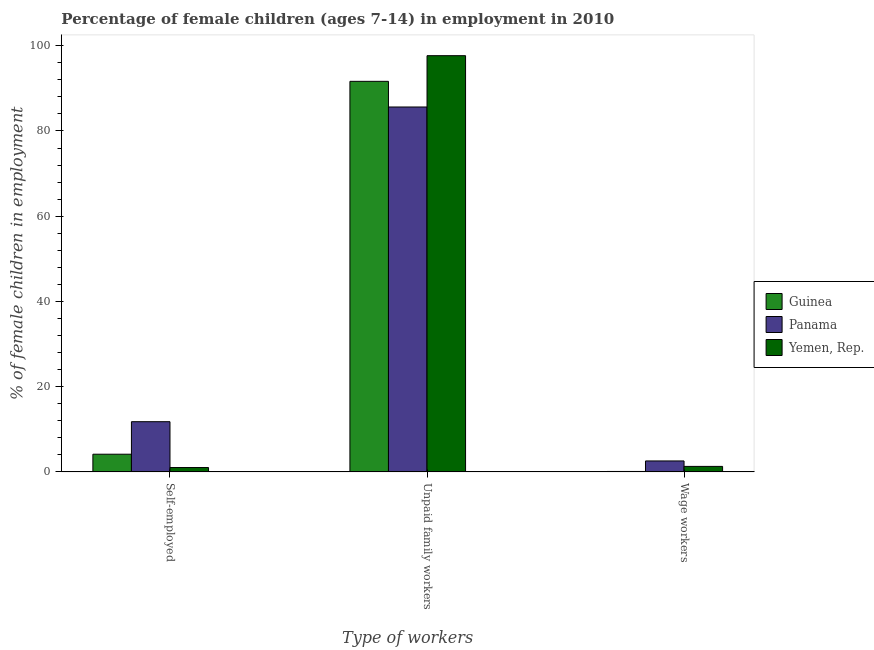How many groups of bars are there?
Keep it short and to the point. 3. Are the number of bars per tick equal to the number of legend labels?
Your response must be concise. Yes. What is the label of the 1st group of bars from the left?
Keep it short and to the point. Self-employed. What is the percentage of children employed as wage workers in Guinea?
Provide a succinct answer. 0.11. Across all countries, what is the maximum percentage of children employed as wage workers?
Offer a terse response. 2.58. Across all countries, what is the minimum percentage of children employed as wage workers?
Provide a succinct answer. 0.11. In which country was the percentage of children employed as wage workers maximum?
Offer a very short reply. Panama. In which country was the percentage of children employed as unpaid family workers minimum?
Give a very brief answer. Panama. What is the total percentage of self employed children in the graph?
Your answer should be very brief. 16.98. What is the difference between the percentage of self employed children in Guinea and that in Panama?
Your answer should be very brief. -7.63. What is the difference between the percentage of children employed as wage workers in Panama and the percentage of self employed children in Yemen, Rep.?
Your answer should be very brief. 1.55. What is the average percentage of children employed as wage workers per country?
Offer a very short reply. 1.33. What is the difference between the percentage of children employed as unpaid family workers and percentage of children employed as wage workers in Panama?
Give a very brief answer. 83.05. What is the ratio of the percentage of children employed as wage workers in Guinea to that in Panama?
Provide a succinct answer. 0.04. Is the difference between the percentage of children employed as wage workers in Yemen, Rep. and Panama greater than the difference between the percentage of children employed as unpaid family workers in Yemen, Rep. and Panama?
Give a very brief answer. No. What is the difference between the highest and the second highest percentage of children employed as unpaid family workers?
Keep it short and to the point. 6.02. What is the difference between the highest and the lowest percentage of children employed as unpaid family workers?
Provide a succinct answer. 12.04. Is the sum of the percentage of self employed children in Guinea and Panama greater than the maximum percentage of children employed as wage workers across all countries?
Provide a short and direct response. Yes. What does the 1st bar from the left in Self-employed represents?
Your response must be concise. Guinea. What does the 2nd bar from the right in Unpaid family workers represents?
Offer a very short reply. Panama. Is it the case that in every country, the sum of the percentage of self employed children and percentage of children employed as unpaid family workers is greater than the percentage of children employed as wage workers?
Offer a very short reply. Yes. How many bars are there?
Your answer should be compact. 9. Are all the bars in the graph horizontal?
Offer a terse response. No. What is the difference between two consecutive major ticks on the Y-axis?
Make the answer very short. 20. Are the values on the major ticks of Y-axis written in scientific E-notation?
Give a very brief answer. No. How many legend labels are there?
Your answer should be very brief. 3. What is the title of the graph?
Your response must be concise. Percentage of female children (ages 7-14) in employment in 2010. Does "Panama" appear as one of the legend labels in the graph?
Ensure brevity in your answer.  Yes. What is the label or title of the X-axis?
Ensure brevity in your answer.  Type of workers. What is the label or title of the Y-axis?
Make the answer very short. % of female children in employment. What is the % of female children in employment in Guinea in Self-employed?
Provide a short and direct response. 4.16. What is the % of female children in employment of Panama in Self-employed?
Your answer should be compact. 11.79. What is the % of female children in employment in Guinea in Unpaid family workers?
Ensure brevity in your answer.  91.65. What is the % of female children in employment in Panama in Unpaid family workers?
Your answer should be very brief. 85.63. What is the % of female children in employment in Yemen, Rep. in Unpaid family workers?
Provide a short and direct response. 97.67. What is the % of female children in employment of Guinea in Wage workers?
Keep it short and to the point. 0.11. What is the % of female children in employment of Panama in Wage workers?
Make the answer very short. 2.58. What is the % of female children in employment of Yemen, Rep. in Wage workers?
Provide a short and direct response. 1.3. Across all Type of workers, what is the maximum % of female children in employment in Guinea?
Offer a very short reply. 91.65. Across all Type of workers, what is the maximum % of female children in employment in Panama?
Keep it short and to the point. 85.63. Across all Type of workers, what is the maximum % of female children in employment in Yemen, Rep.?
Your answer should be compact. 97.67. Across all Type of workers, what is the minimum % of female children in employment of Guinea?
Make the answer very short. 0.11. Across all Type of workers, what is the minimum % of female children in employment of Panama?
Give a very brief answer. 2.58. Across all Type of workers, what is the minimum % of female children in employment of Yemen, Rep.?
Give a very brief answer. 1.03. What is the total % of female children in employment in Guinea in the graph?
Provide a short and direct response. 95.92. What is the total % of female children in employment of Panama in the graph?
Make the answer very short. 100. What is the difference between the % of female children in employment of Guinea in Self-employed and that in Unpaid family workers?
Offer a terse response. -87.49. What is the difference between the % of female children in employment in Panama in Self-employed and that in Unpaid family workers?
Ensure brevity in your answer.  -73.84. What is the difference between the % of female children in employment in Yemen, Rep. in Self-employed and that in Unpaid family workers?
Offer a very short reply. -96.64. What is the difference between the % of female children in employment of Guinea in Self-employed and that in Wage workers?
Your answer should be compact. 4.05. What is the difference between the % of female children in employment in Panama in Self-employed and that in Wage workers?
Your answer should be very brief. 9.21. What is the difference between the % of female children in employment in Yemen, Rep. in Self-employed and that in Wage workers?
Ensure brevity in your answer.  -0.27. What is the difference between the % of female children in employment in Guinea in Unpaid family workers and that in Wage workers?
Provide a succinct answer. 91.54. What is the difference between the % of female children in employment in Panama in Unpaid family workers and that in Wage workers?
Ensure brevity in your answer.  83.05. What is the difference between the % of female children in employment in Yemen, Rep. in Unpaid family workers and that in Wage workers?
Provide a short and direct response. 96.37. What is the difference between the % of female children in employment of Guinea in Self-employed and the % of female children in employment of Panama in Unpaid family workers?
Make the answer very short. -81.47. What is the difference between the % of female children in employment of Guinea in Self-employed and the % of female children in employment of Yemen, Rep. in Unpaid family workers?
Your answer should be very brief. -93.51. What is the difference between the % of female children in employment in Panama in Self-employed and the % of female children in employment in Yemen, Rep. in Unpaid family workers?
Provide a short and direct response. -85.88. What is the difference between the % of female children in employment in Guinea in Self-employed and the % of female children in employment in Panama in Wage workers?
Your answer should be very brief. 1.58. What is the difference between the % of female children in employment in Guinea in Self-employed and the % of female children in employment in Yemen, Rep. in Wage workers?
Keep it short and to the point. 2.86. What is the difference between the % of female children in employment in Panama in Self-employed and the % of female children in employment in Yemen, Rep. in Wage workers?
Your answer should be very brief. 10.49. What is the difference between the % of female children in employment in Guinea in Unpaid family workers and the % of female children in employment in Panama in Wage workers?
Offer a terse response. 89.07. What is the difference between the % of female children in employment in Guinea in Unpaid family workers and the % of female children in employment in Yemen, Rep. in Wage workers?
Ensure brevity in your answer.  90.35. What is the difference between the % of female children in employment of Panama in Unpaid family workers and the % of female children in employment of Yemen, Rep. in Wage workers?
Your answer should be very brief. 84.33. What is the average % of female children in employment of Guinea per Type of workers?
Offer a terse response. 31.97. What is the average % of female children in employment in Panama per Type of workers?
Make the answer very short. 33.33. What is the average % of female children in employment in Yemen, Rep. per Type of workers?
Keep it short and to the point. 33.33. What is the difference between the % of female children in employment in Guinea and % of female children in employment in Panama in Self-employed?
Ensure brevity in your answer.  -7.63. What is the difference between the % of female children in employment in Guinea and % of female children in employment in Yemen, Rep. in Self-employed?
Offer a very short reply. 3.13. What is the difference between the % of female children in employment of Panama and % of female children in employment of Yemen, Rep. in Self-employed?
Keep it short and to the point. 10.76. What is the difference between the % of female children in employment in Guinea and % of female children in employment in Panama in Unpaid family workers?
Make the answer very short. 6.02. What is the difference between the % of female children in employment of Guinea and % of female children in employment of Yemen, Rep. in Unpaid family workers?
Your answer should be very brief. -6.02. What is the difference between the % of female children in employment in Panama and % of female children in employment in Yemen, Rep. in Unpaid family workers?
Provide a short and direct response. -12.04. What is the difference between the % of female children in employment in Guinea and % of female children in employment in Panama in Wage workers?
Ensure brevity in your answer.  -2.47. What is the difference between the % of female children in employment of Guinea and % of female children in employment of Yemen, Rep. in Wage workers?
Give a very brief answer. -1.19. What is the difference between the % of female children in employment in Panama and % of female children in employment in Yemen, Rep. in Wage workers?
Give a very brief answer. 1.28. What is the ratio of the % of female children in employment of Guinea in Self-employed to that in Unpaid family workers?
Provide a short and direct response. 0.05. What is the ratio of the % of female children in employment in Panama in Self-employed to that in Unpaid family workers?
Give a very brief answer. 0.14. What is the ratio of the % of female children in employment of Yemen, Rep. in Self-employed to that in Unpaid family workers?
Give a very brief answer. 0.01. What is the ratio of the % of female children in employment of Guinea in Self-employed to that in Wage workers?
Make the answer very short. 37.82. What is the ratio of the % of female children in employment of Panama in Self-employed to that in Wage workers?
Keep it short and to the point. 4.57. What is the ratio of the % of female children in employment in Yemen, Rep. in Self-employed to that in Wage workers?
Make the answer very short. 0.79. What is the ratio of the % of female children in employment of Guinea in Unpaid family workers to that in Wage workers?
Your answer should be compact. 833.18. What is the ratio of the % of female children in employment in Panama in Unpaid family workers to that in Wage workers?
Provide a short and direct response. 33.19. What is the ratio of the % of female children in employment in Yemen, Rep. in Unpaid family workers to that in Wage workers?
Offer a very short reply. 75.13. What is the difference between the highest and the second highest % of female children in employment of Guinea?
Offer a terse response. 87.49. What is the difference between the highest and the second highest % of female children in employment of Panama?
Offer a very short reply. 73.84. What is the difference between the highest and the second highest % of female children in employment in Yemen, Rep.?
Make the answer very short. 96.37. What is the difference between the highest and the lowest % of female children in employment in Guinea?
Your answer should be compact. 91.54. What is the difference between the highest and the lowest % of female children in employment in Panama?
Give a very brief answer. 83.05. What is the difference between the highest and the lowest % of female children in employment of Yemen, Rep.?
Your answer should be compact. 96.64. 